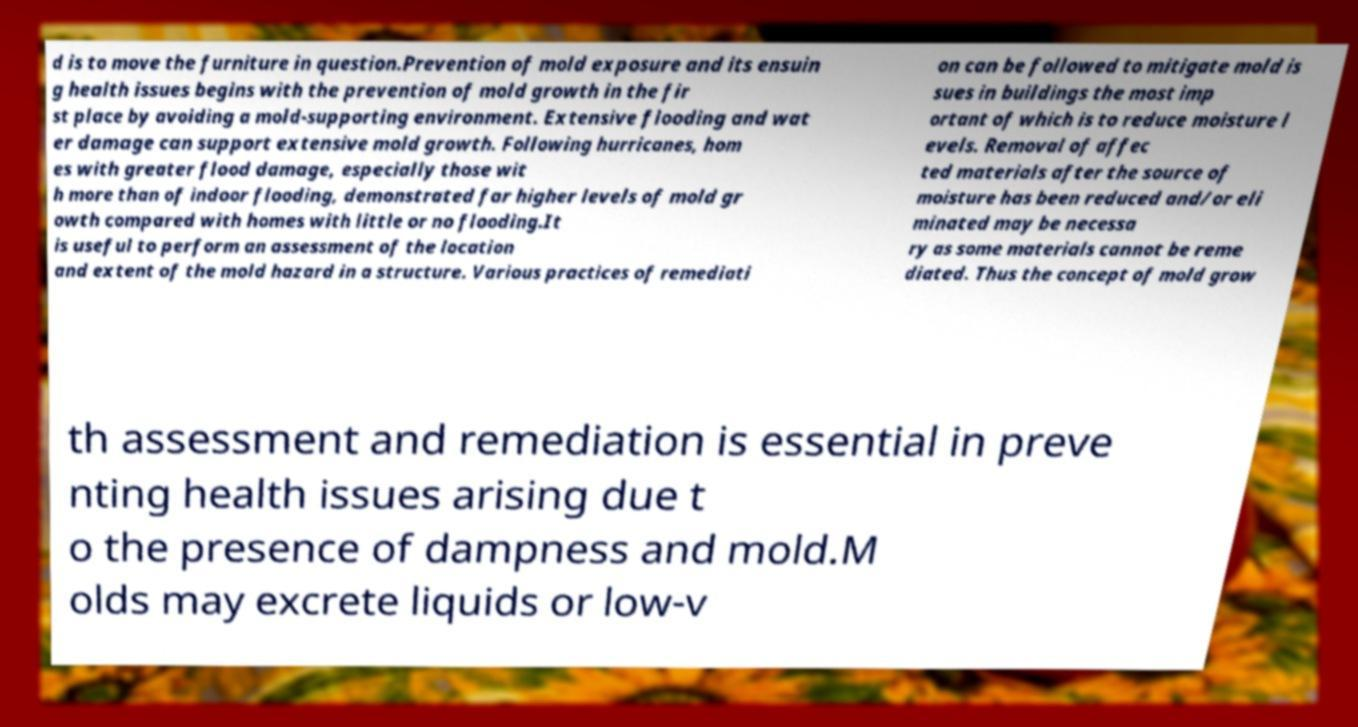Could you assist in decoding the text presented in this image and type it out clearly? d is to move the furniture in question.Prevention of mold exposure and its ensuin g health issues begins with the prevention of mold growth in the fir st place by avoiding a mold-supporting environment. Extensive flooding and wat er damage can support extensive mold growth. Following hurricanes, hom es with greater flood damage, especially those wit h more than of indoor flooding, demonstrated far higher levels of mold gr owth compared with homes with little or no flooding.It is useful to perform an assessment of the location and extent of the mold hazard in a structure. Various practices of remediati on can be followed to mitigate mold is sues in buildings the most imp ortant of which is to reduce moisture l evels. Removal of affec ted materials after the source of moisture has been reduced and/or eli minated may be necessa ry as some materials cannot be reme diated. Thus the concept of mold grow th assessment and remediation is essential in preve nting health issues arising due t o the presence of dampness and mold.M olds may excrete liquids or low-v 